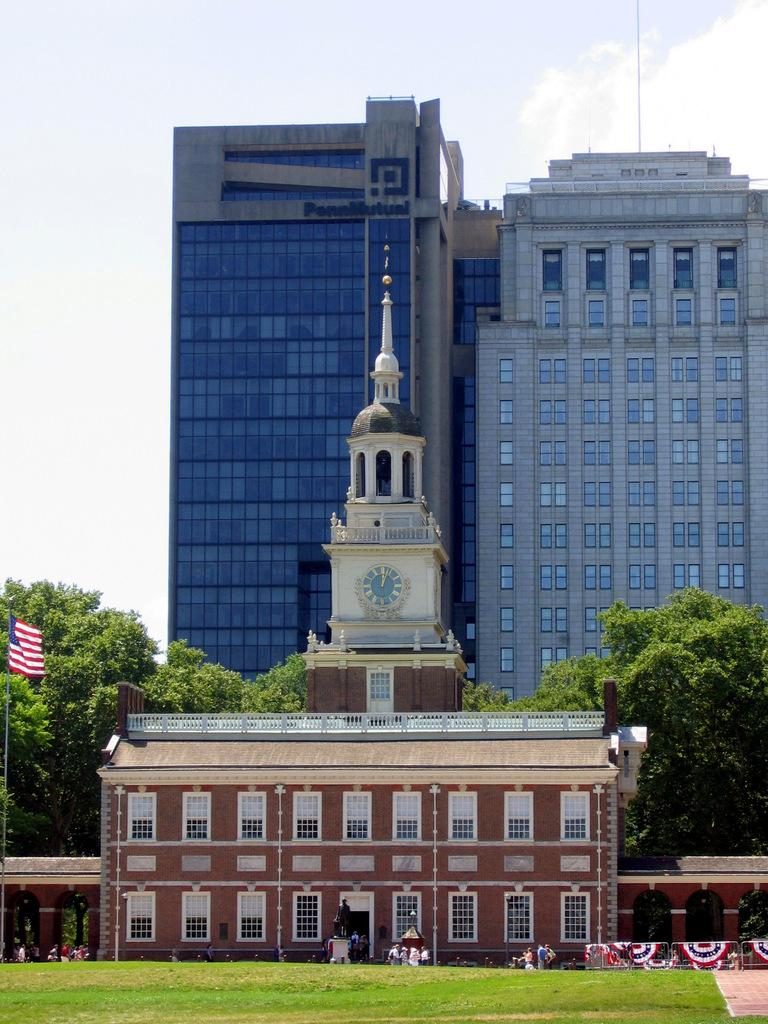What type of landscape is depicted in the image? There is a grassland in the image. What can be seen in the background of the grassland? There is a flag pole, buildings, trees, and the sky visible in the background of the image. What is the smell of the milk in the image? There is no milk present in the image, so it is not possible to determine its smell. 